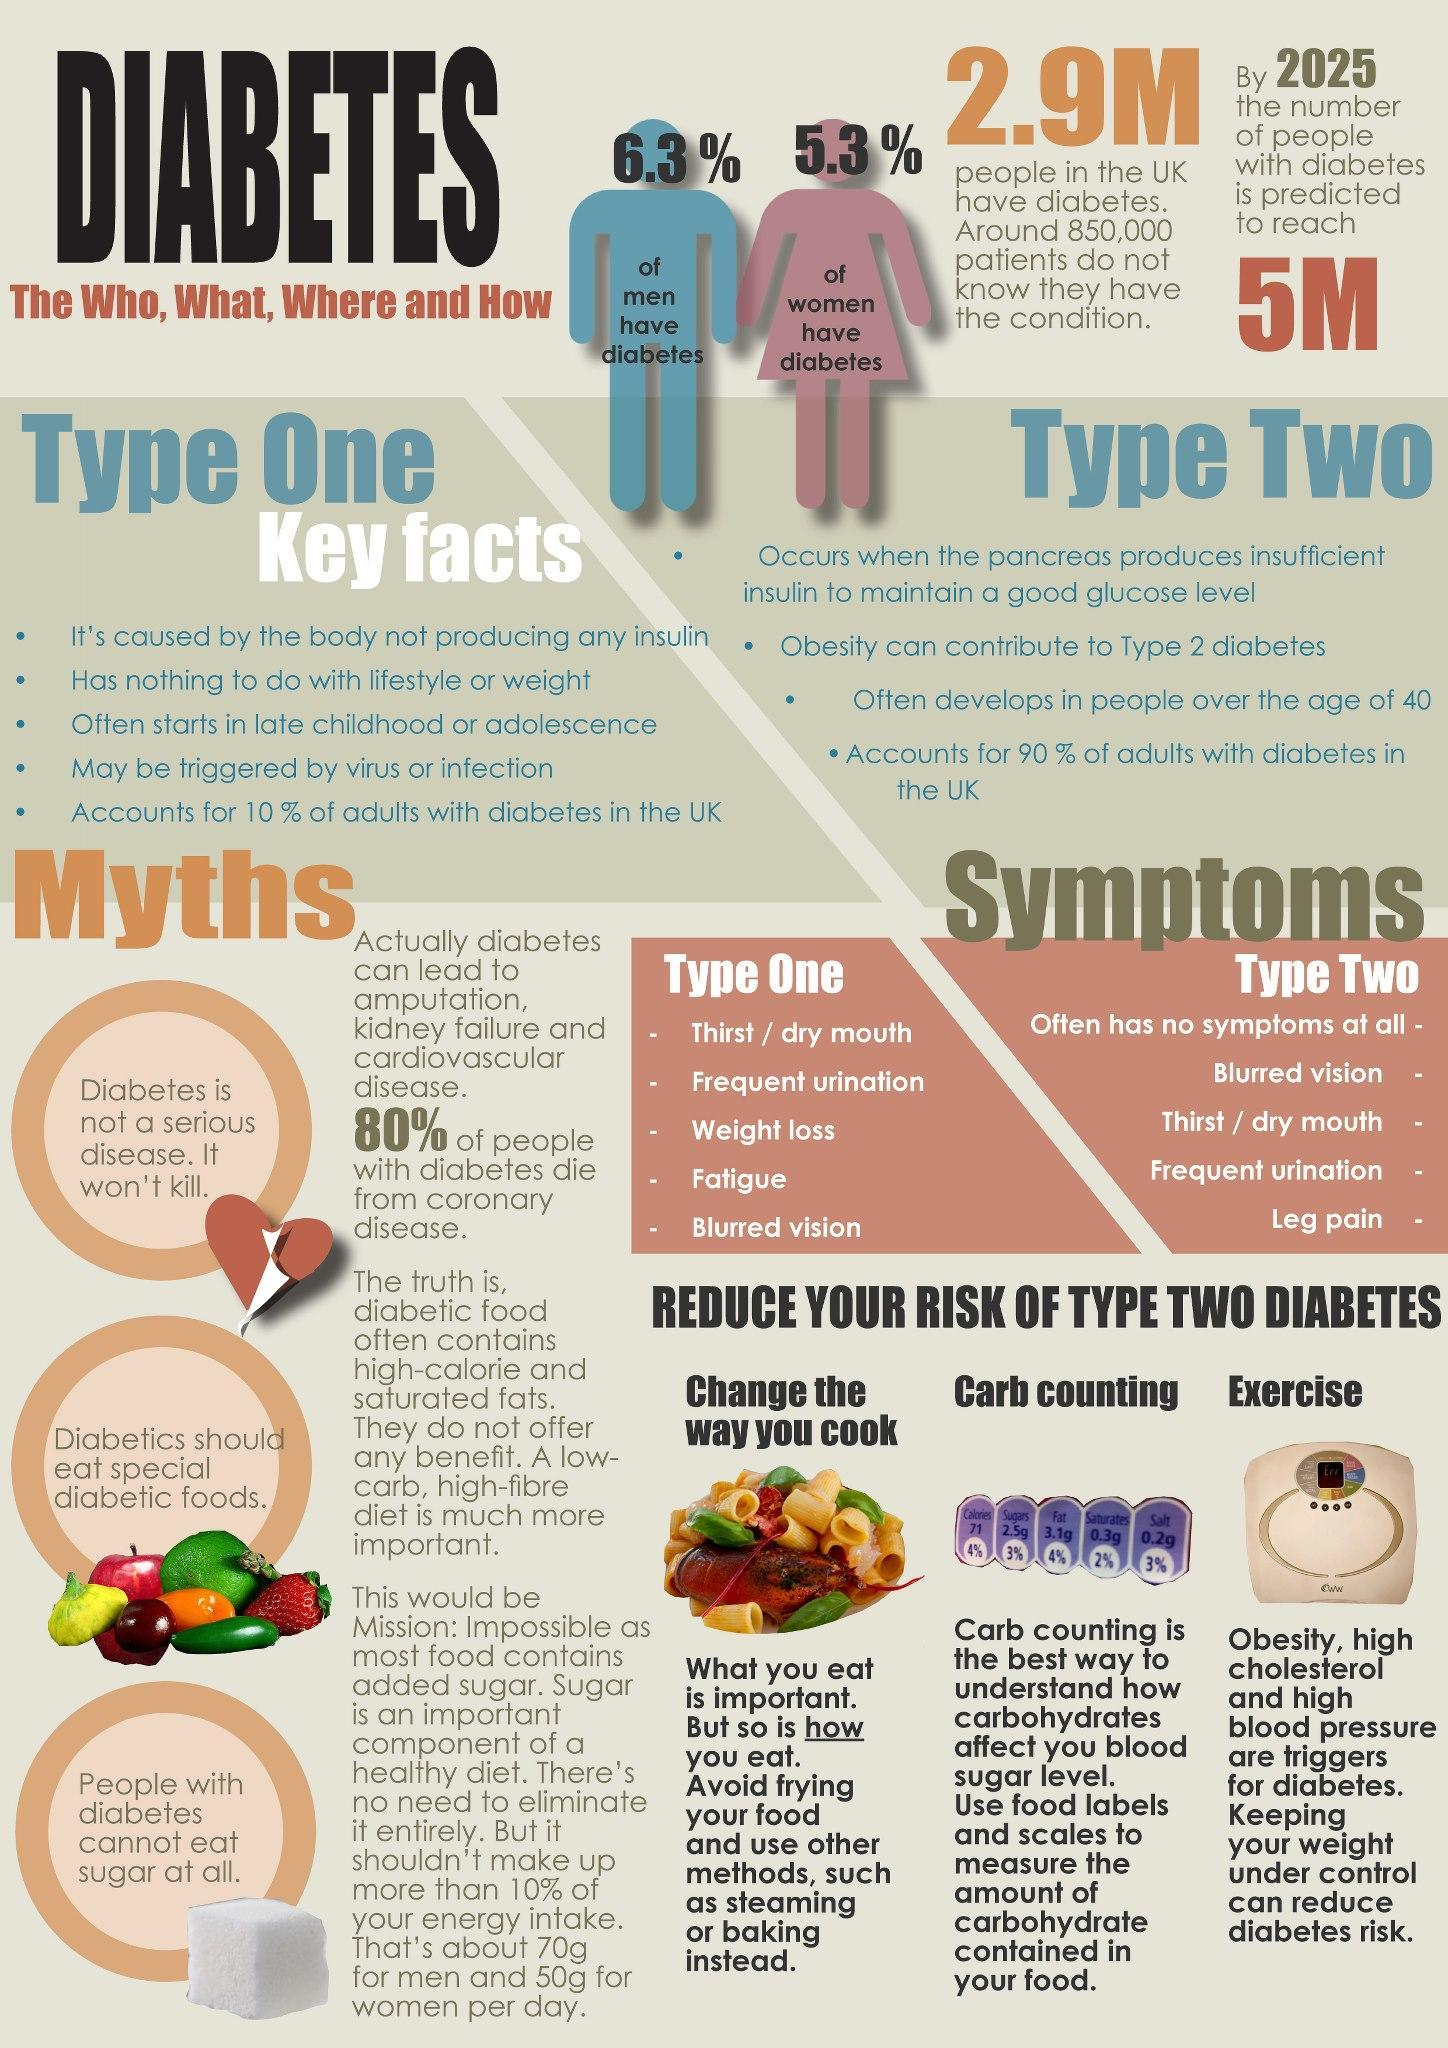What are the last three symptoms of the list of type 1 diabetes given?
Answer the question with a short phrase. weight loss, fatigue, blurred vision What is third in the list of key facts of type two? often develops in people over the age of 40 What are the three main points given here to reduce the risk of type 2 diabetes? change the way you cook, carb counting, exercise What are the last three symptoms of the list of type 2 diabetes given? thirst / dry mouth, frequent urination, leg pain How many myths about diabetes are given in the graphics? 3 Which type of diabetes is found more in the UK? type two What are the two symptoms of type1 diabetes Which are not given in the list of type 2 symptoms? weight loss, fatigue What is the second myth given in the graphics? diabetics should eat special diabetic foods. Who is more prone to diabetes - men or women? men What is fourth in the list of key facts of type one? may be triggered by virus or infection 